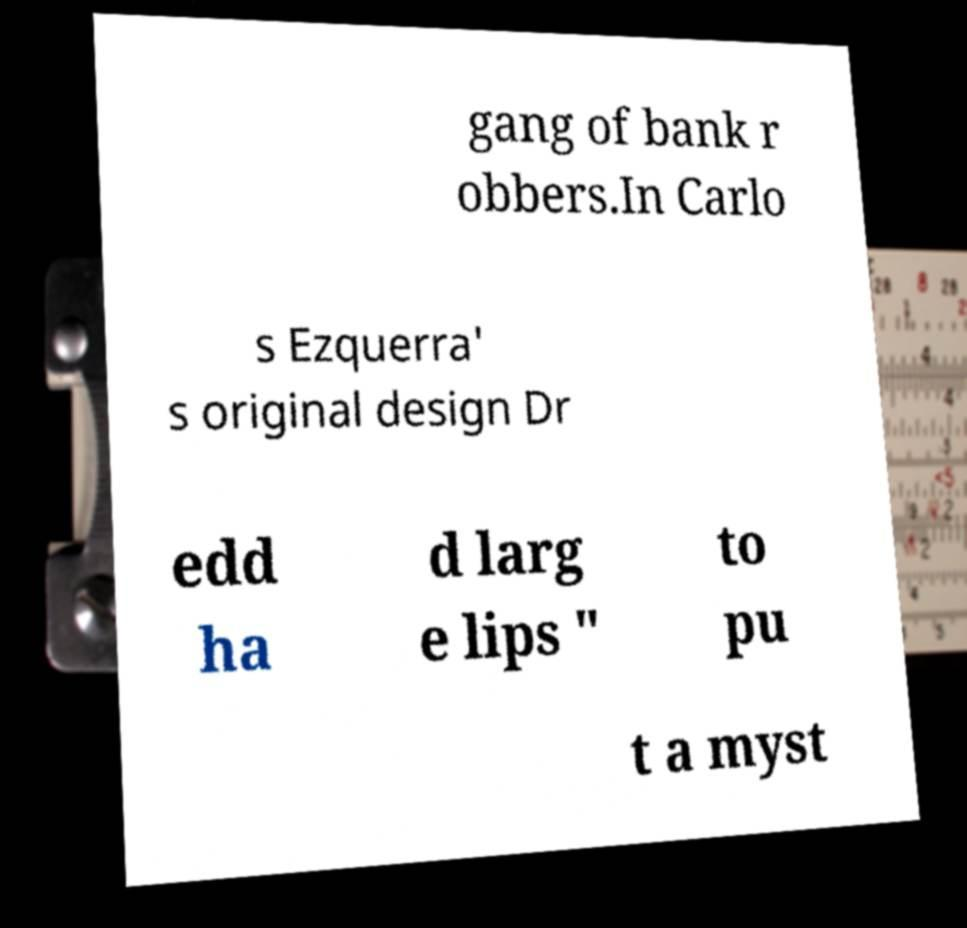Could you assist in decoding the text presented in this image and type it out clearly? gang of bank r obbers.In Carlo s Ezquerra' s original design Dr edd ha d larg e lips " to pu t a myst 